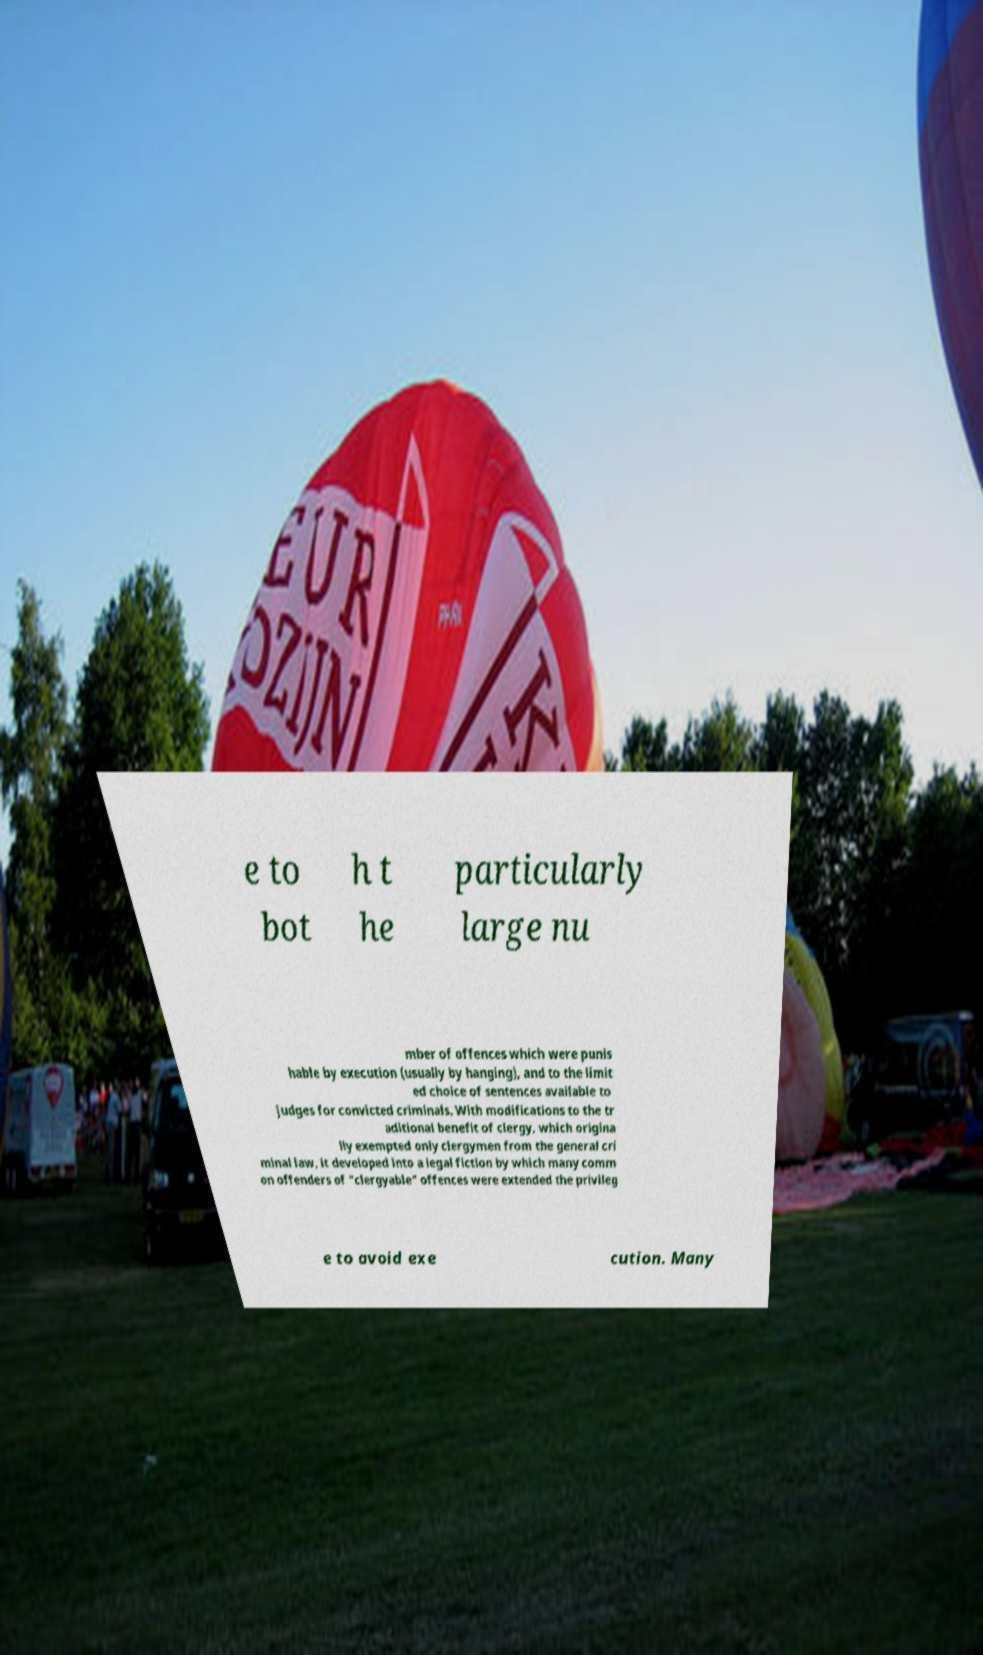For documentation purposes, I need the text within this image transcribed. Could you provide that? e to bot h t he particularly large nu mber of offences which were punis hable by execution (usually by hanging), and to the limit ed choice of sentences available to judges for convicted criminals. With modifications to the tr aditional benefit of clergy, which origina lly exempted only clergymen from the general cri minal law, it developed into a legal fiction by which many comm on offenders of "clergyable" offences were extended the privileg e to avoid exe cution. Many 